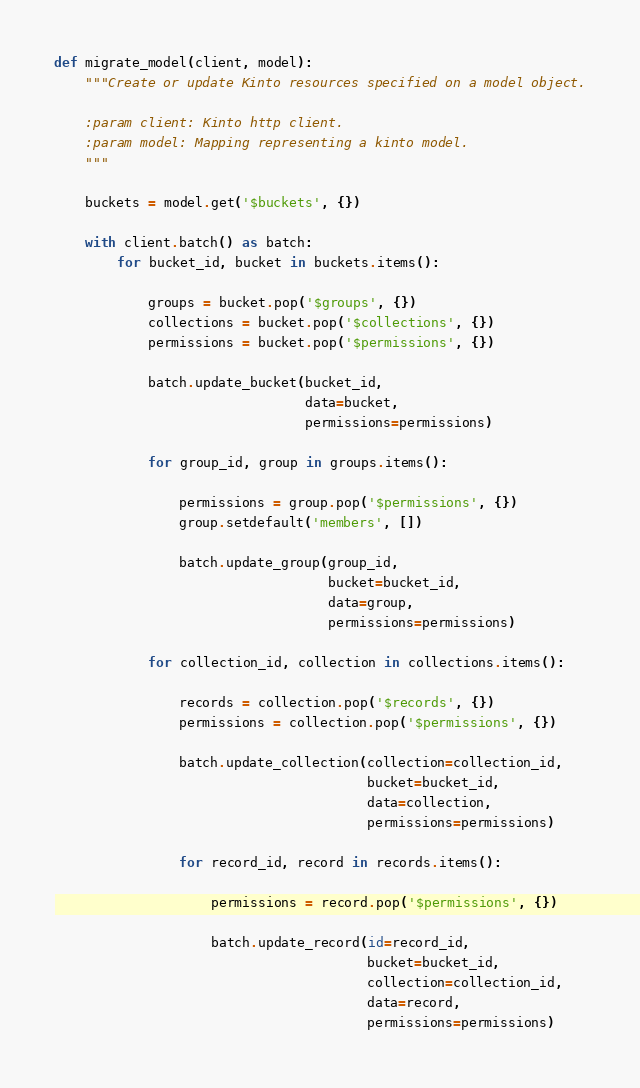<code> <loc_0><loc_0><loc_500><loc_500><_Python_>def migrate_model(client, model):
    """Create or update Kinto resources specified on a model object.

    :param client: Kinto http client.
    :param model: Mapping representing a kinto model.
    """

    buckets = model.get('$buckets', {})

    with client.batch() as batch:
        for bucket_id, bucket in buckets.items():

            groups = bucket.pop('$groups', {})
            collections = bucket.pop('$collections', {})
            permissions = bucket.pop('$permissions', {})

            batch.update_bucket(bucket_id,
                                data=bucket,
                                permissions=permissions)

            for group_id, group in groups.items():

                permissions = group.pop('$permissions', {})
                group.setdefault('members', [])

                batch.update_group(group_id,
                                   bucket=bucket_id,
                                   data=group,
                                   permissions=permissions)

            for collection_id, collection in collections.items():

                records = collection.pop('$records', {})
                permissions = collection.pop('$permissions', {})

                batch.update_collection(collection=collection_id,
                                        bucket=bucket_id,
                                        data=collection,
                                        permissions=permissions)

                for record_id, record in records.items():

                    permissions = record.pop('$permissions', {})

                    batch.update_record(id=record_id,
                                        bucket=bucket_id,
                                        collection=collection_id,
                                        data=record,
                                        permissions=permissions)
</code> 